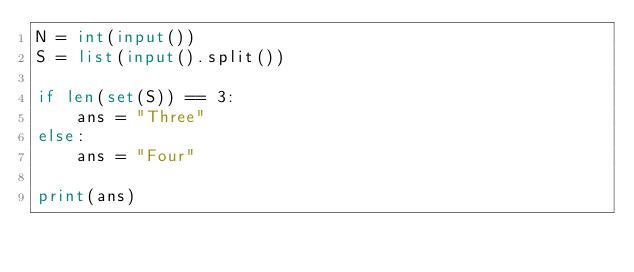Convert code to text. <code><loc_0><loc_0><loc_500><loc_500><_Python_>N = int(input())
S = list(input().split())

if len(set(S)) == 3:
    ans = "Three"
else:
    ans = "Four"

print(ans)</code> 